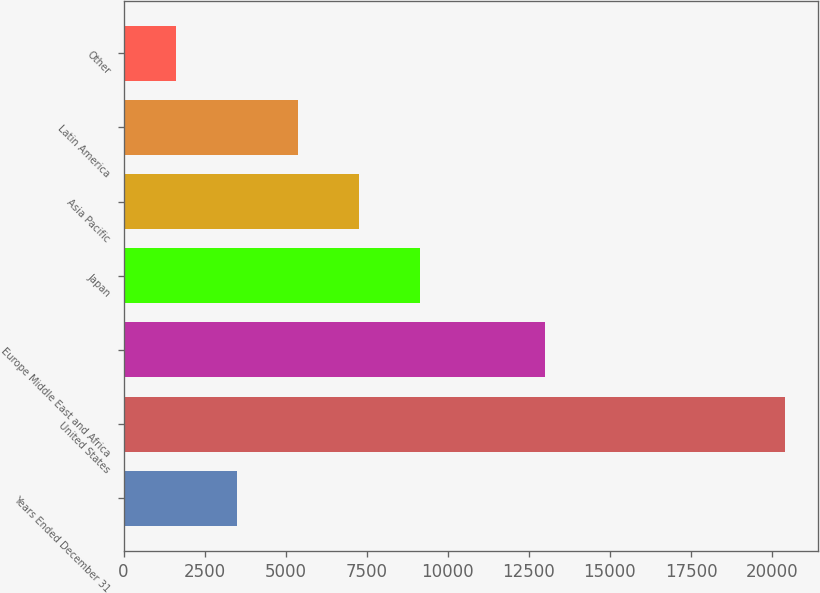Convert chart. <chart><loc_0><loc_0><loc_500><loc_500><bar_chart><fcel>Years Ended December 31<fcel>United States<fcel>Europe Middle East and Africa<fcel>Japan<fcel>Asia Pacific<fcel>Latin America<fcel>Other<nl><fcel>3496.3<fcel>20392<fcel>12990<fcel>9128.2<fcel>7250.9<fcel>5373.6<fcel>1619<nl></chart> 